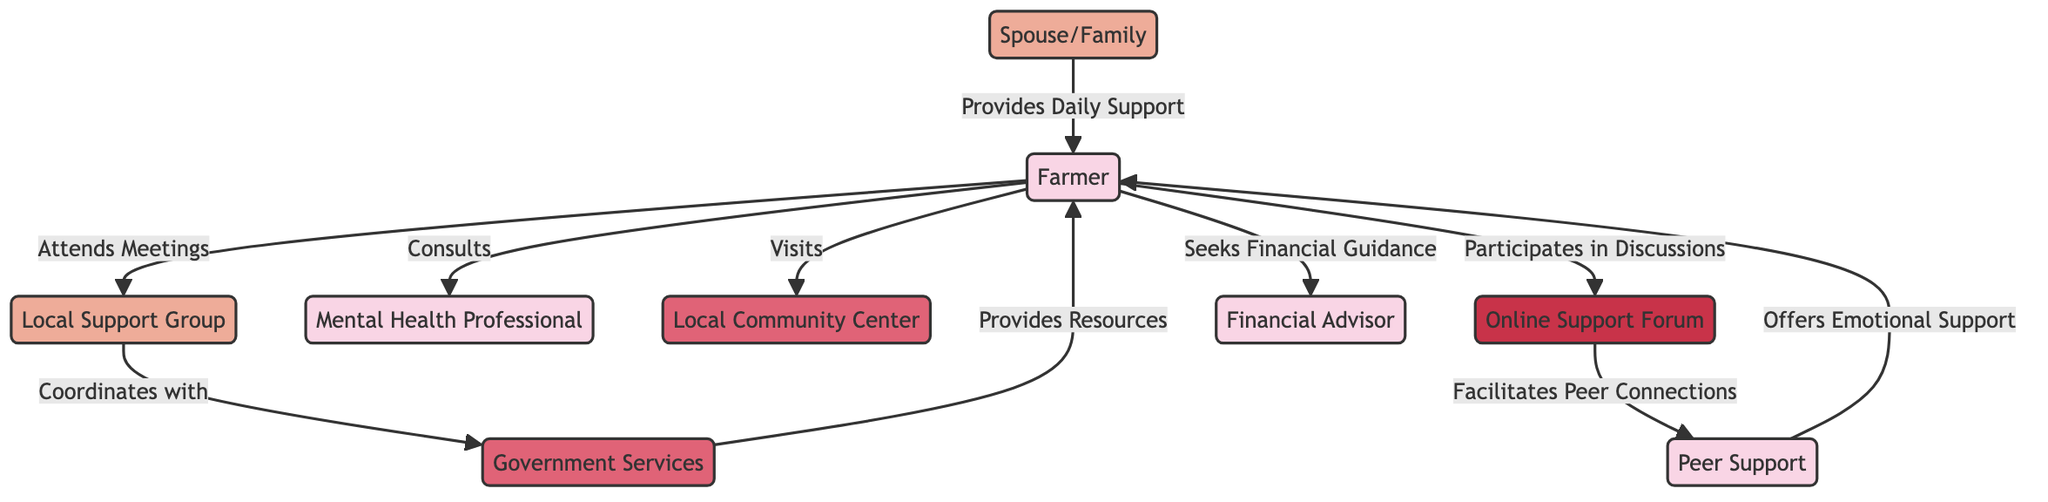What's the total number of nodes in the diagram? By counting the unique entities represented in the diagram, we see that there are 9 distinct nodes: Farmer, Local Support Group, Mental Health Professional, Local Community Center, Government Services, Online Support Forum, Peer Support, Spouse/Family, and Financial Advisor.
Answer: 9 How many edges are connected to the farmer? The farmer has 6 connections (edges) to other nodes: Local Support Group, Mental Health Professional, Local Community Center, Online Support Forum, Peer Support, and Financial Advisor.
Answer: 6 What relationship does the local support group have with the government services? The diagram shows that the local support group has a coordinating relationship with government services.
Answer: Coordinates with Who provides daily support to the farmer? The diagram indicates that the spouse/family provides daily support to the farmer, as depicted by the connection between these two nodes.
Answer: Spouse/Family Which node directly connects the online support forum and the farmer? According to the diagram, the online support forum connects to the farmer through the relationship of participating in discussions.
Answer: Participates in Discussions What type of organization is the local community center? Referring to the type categorization in the diagram, the local community center is classified under organizations.
Answer: Organization Which individual does the farmer consult for mental health assistance? The diagram clearly shows a direct connection from the farmer to the mental health professional for consultations regarding mental health.
Answer: Mental Health Professional How does peer support engage with the farmer? The peer support interacts with the farmer by offering emotional support, as illustrated by the connecting edge between these two nodes.
Answer: Offers Emotional Support What is the primary role of government services concerning the farmer? The diagram indicates that the government services provide resources to the farmer, thus clarifying their function within the support network.
Answer: Provides Resources 